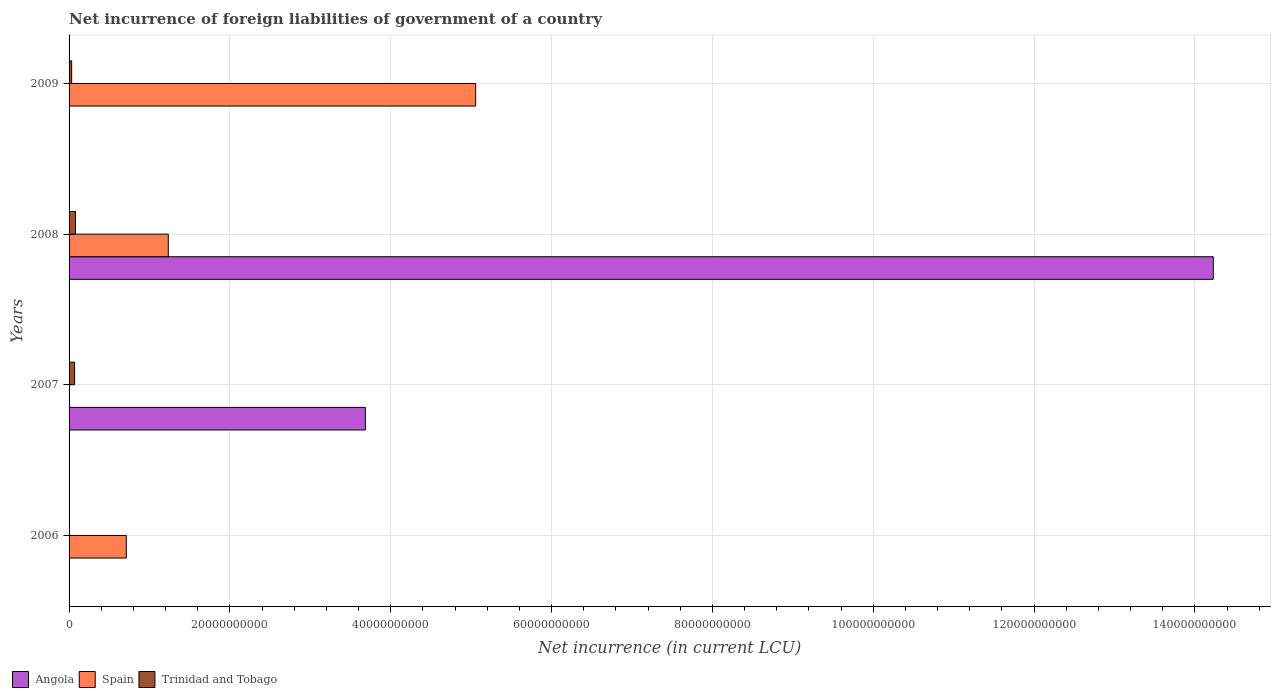How many bars are there on the 4th tick from the bottom?
Provide a short and direct response. 2. In how many cases, is the number of bars for a given year not equal to the number of legend labels?
Provide a short and direct response. 3. Across all years, what is the maximum net incurrence of foreign liabilities in Trinidad and Tobago?
Ensure brevity in your answer.  7.97e+08. Across all years, what is the minimum net incurrence of foreign liabilities in Angola?
Ensure brevity in your answer.  0. In which year was the net incurrence of foreign liabilities in Trinidad and Tobago maximum?
Offer a terse response. 2008. What is the total net incurrence of foreign liabilities in Trinidad and Tobago in the graph?
Offer a terse response. 1.81e+09. What is the difference between the net incurrence of foreign liabilities in Angola in 2007 and that in 2008?
Offer a terse response. -1.05e+11. What is the difference between the net incurrence of foreign liabilities in Angola in 2006 and the net incurrence of foreign liabilities in Trinidad and Tobago in 2009?
Give a very brief answer. -3.23e+08. What is the average net incurrence of foreign liabilities in Trinidad and Tobago per year?
Keep it short and to the point. 4.52e+08. In the year 2009, what is the difference between the net incurrence of foreign liabilities in Trinidad and Tobago and net incurrence of foreign liabilities in Spain?
Give a very brief answer. -5.02e+1. In how many years, is the net incurrence of foreign liabilities in Spain greater than 4000000000 LCU?
Your response must be concise. 3. What is the ratio of the net incurrence of foreign liabilities in Spain in 2006 to that in 2008?
Ensure brevity in your answer.  0.58. Is the net incurrence of foreign liabilities in Angola in 2007 less than that in 2008?
Offer a very short reply. Yes. What is the difference between the highest and the second highest net incurrence of foreign liabilities in Spain?
Provide a short and direct response. 3.82e+1. What is the difference between the highest and the lowest net incurrence of foreign liabilities in Trinidad and Tobago?
Your answer should be very brief. 7.97e+08. Is the sum of the net incurrence of foreign liabilities in Angola in 2007 and 2008 greater than the maximum net incurrence of foreign liabilities in Spain across all years?
Offer a very short reply. Yes. Is it the case that in every year, the sum of the net incurrence of foreign liabilities in Trinidad and Tobago and net incurrence of foreign liabilities in Angola is greater than the net incurrence of foreign liabilities in Spain?
Offer a very short reply. No. How many years are there in the graph?
Provide a short and direct response. 4. What is the difference between two consecutive major ticks on the X-axis?
Provide a succinct answer. 2.00e+1. Does the graph contain any zero values?
Provide a succinct answer. Yes. Where does the legend appear in the graph?
Your answer should be compact. Bottom left. How are the legend labels stacked?
Offer a very short reply. Horizontal. What is the title of the graph?
Give a very brief answer. Net incurrence of foreign liabilities of government of a country. What is the label or title of the X-axis?
Provide a short and direct response. Net incurrence (in current LCU). What is the Net incurrence (in current LCU) in Spain in 2006?
Offer a very short reply. 7.12e+09. What is the Net incurrence (in current LCU) of Trinidad and Tobago in 2006?
Provide a succinct answer. 0. What is the Net incurrence (in current LCU) in Angola in 2007?
Offer a very short reply. 3.68e+1. What is the Net incurrence (in current LCU) of Trinidad and Tobago in 2007?
Your response must be concise. 6.88e+08. What is the Net incurrence (in current LCU) of Angola in 2008?
Your answer should be compact. 1.42e+11. What is the Net incurrence (in current LCU) in Spain in 2008?
Your answer should be compact. 1.23e+1. What is the Net incurrence (in current LCU) of Trinidad and Tobago in 2008?
Your answer should be compact. 7.97e+08. What is the Net incurrence (in current LCU) in Angola in 2009?
Keep it short and to the point. 0. What is the Net incurrence (in current LCU) of Spain in 2009?
Provide a short and direct response. 5.06e+1. What is the Net incurrence (in current LCU) of Trinidad and Tobago in 2009?
Ensure brevity in your answer.  3.23e+08. Across all years, what is the maximum Net incurrence (in current LCU) of Angola?
Ensure brevity in your answer.  1.42e+11. Across all years, what is the maximum Net incurrence (in current LCU) in Spain?
Your response must be concise. 5.06e+1. Across all years, what is the maximum Net incurrence (in current LCU) in Trinidad and Tobago?
Provide a short and direct response. 7.97e+08. Across all years, what is the minimum Net incurrence (in current LCU) of Angola?
Your answer should be compact. 0. Across all years, what is the minimum Net incurrence (in current LCU) of Spain?
Your answer should be compact. 0. What is the total Net incurrence (in current LCU) of Angola in the graph?
Ensure brevity in your answer.  1.79e+11. What is the total Net incurrence (in current LCU) in Spain in the graph?
Make the answer very short. 7.00e+1. What is the total Net incurrence (in current LCU) in Trinidad and Tobago in the graph?
Provide a short and direct response. 1.81e+09. What is the difference between the Net incurrence (in current LCU) of Spain in 2006 and that in 2008?
Give a very brief answer. -5.22e+09. What is the difference between the Net incurrence (in current LCU) of Spain in 2006 and that in 2009?
Your response must be concise. -4.34e+1. What is the difference between the Net incurrence (in current LCU) in Angola in 2007 and that in 2008?
Your answer should be very brief. -1.05e+11. What is the difference between the Net incurrence (in current LCU) of Trinidad and Tobago in 2007 and that in 2008?
Make the answer very short. -1.08e+08. What is the difference between the Net incurrence (in current LCU) of Trinidad and Tobago in 2007 and that in 2009?
Your answer should be very brief. 3.65e+08. What is the difference between the Net incurrence (in current LCU) of Spain in 2008 and that in 2009?
Ensure brevity in your answer.  -3.82e+1. What is the difference between the Net incurrence (in current LCU) of Trinidad and Tobago in 2008 and that in 2009?
Ensure brevity in your answer.  4.73e+08. What is the difference between the Net incurrence (in current LCU) of Spain in 2006 and the Net incurrence (in current LCU) of Trinidad and Tobago in 2007?
Keep it short and to the point. 6.43e+09. What is the difference between the Net incurrence (in current LCU) of Spain in 2006 and the Net incurrence (in current LCU) of Trinidad and Tobago in 2008?
Make the answer very short. 6.32e+09. What is the difference between the Net incurrence (in current LCU) of Spain in 2006 and the Net incurrence (in current LCU) of Trinidad and Tobago in 2009?
Give a very brief answer. 6.79e+09. What is the difference between the Net incurrence (in current LCU) in Angola in 2007 and the Net incurrence (in current LCU) in Spain in 2008?
Make the answer very short. 2.45e+1. What is the difference between the Net incurrence (in current LCU) in Angola in 2007 and the Net incurrence (in current LCU) in Trinidad and Tobago in 2008?
Offer a very short reply. 3.60e+1. What is the difference between the Net incurrence (in current LCU) of Angola in 2007 and the Net incurrence (in current LCU) of Spain in 2009?
Your answer should be compact. -1.37e+1. What is the difference between the Net incurrence (in current LCU) of Angola in 2007 and the Net incurrence (in current LCU) of Trinidad and Tobago in 2009?
Provide a succinct answer. 3.65e+1. What is the difference between the Net incurrence (in current LCU) of Angola in 2008 and the Net incurrence (in current LCU) of Spain in 2009?
Make the answer very short. 9.17e+1. What is the difference between the Net incurrence (in current LCU) of Angola in 2008 and the Net incurrence (in current LCU) of Trinidad and Tobago in 2009?
Make the answer very short. 1.42e+11. What is the difference between the Net incurrence (in current LCU) in Spain in 2008 and the Net incurrence (in current LCU) in Trinidad and Tobago in 2009?
Offer a very short reply. 1.20e+1. What is the average Net incurrence (in current LCU) in Angola per year?
Provide a short and direct response. 4.48e+1. What is the average Net incurrence (in current LCU) of Spain per year?
Keep it short and to the point. 1.75e+1. What is the average Net incurrence (in current LCU) of Trinidad and Tobago per year?
Provide a short and direct response. 4.52e+08. In the year 2007, what is the difference between the Net incurrence (in current LCU) of Angola and Net incurrence (in current LCU) of Trinidad and Tobago?
Ensure brevity in your answer.  3.62e+1. In the year 2008, what is the difference between the Net incurrence (in current LCU) of Angola and Net incurrence (in current LCU) of Spain?
Give a very brief answer. 1.30e+11. In the year 2008, what is the difference between the Net incurrence (in current LCU) in Angola and Net incurrence (in current LCU) in Trinidad and Tobago?
Make the answer very short. 1.41e+11. In the year 2008, what is the difference between the Net incurrence (in current LCU) in Spain and Net incurrence (in current LCU) in Trinidad and Tobago?
Your answer should be compact. 1.15e+1. In the year 2009, what is the difference between the Net incurrence (in current LCU) in Spain and Net incurrence (in current LCU) in Trinidad and Tobago?
Provide a succinct answer. 5.02e+1. What is the ratio of the Net incurrence (in current LCU) of Spain in 2006 to that in 2008?
Keep it short and to the point. 0.58. What is the ratio of the Net incurrence (in current LCU) of Spain in 2006 to that in 2009?
Provide a succinct answer. 0.14. What is the ratio of the Net incurrence (in current LCU) in Angola in 2007 to that in 2008?
Provide a short and direct response. 0.26. What is the ratio of the Net incurrence (in current LCU) in Trinidad and Tobago in 2007 to that in 2008?
Provide a succinct answer. 0.86. What is the ratio of the Net incurrence (in current LCU) of Trinidad and Tobago in 2007 to that in 2009?
Make the answer very short. 2.13. What is the ratio of the Net incurrence (in current LCU) in Spain in 2008 to that in 2009?
Keep it short and to the point. 0.24. What is the ratio of the Net incurrence (in current LCU) in Trinidad and Tobago in 2008 to that in 2009?
Provide a succinct answer. 2.46. What is the difference between the highest and the second highest Net incurrence (in current LCU) of Spain?
Ensure brevity in your answer.  3.82e+1. What is the difference between the highest and the second highest Net incurrence (in current LCU) in Trinidad and Tobago?
Make the answer very short. 1.08e+08. What is the difference between the highest and the lowest Net incurrence (in current LCU) in Angola?
Provide a succinct answer. 1.42e+11. What is the difference between the highest and the lowest Net incurrence (in current LCU) of Spain?
Ensure brevity in your answer.  5.06e+1. What is the difference between the highest and the lowest Net incurrence (in current LCU) of Trinidad and Tobago?
Give a very brief answer. 7.97e+08. 